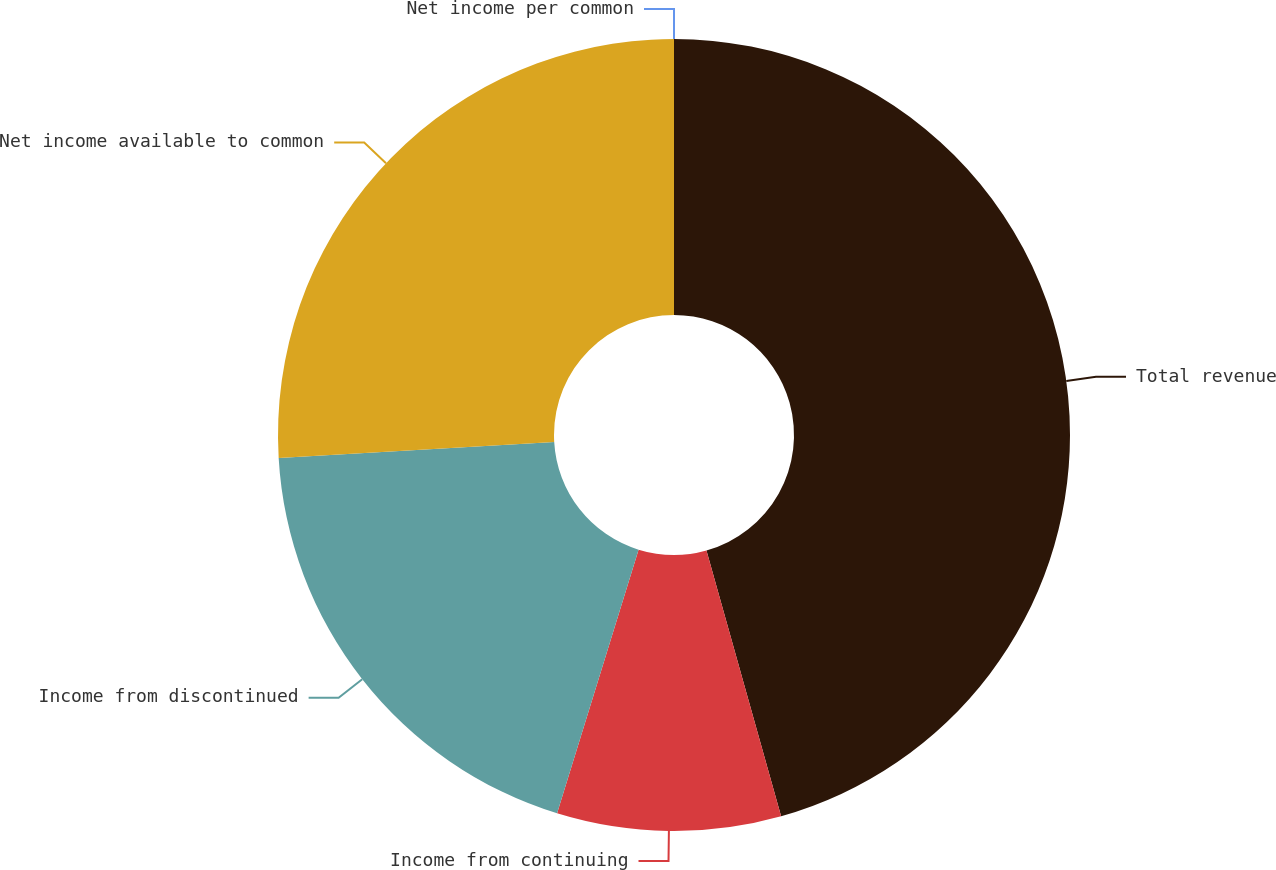<chart> <loc_0><loc_0><loc_500><loc_500><pie_chart><fcel>Total revenue<fcel>Income from continuing<fcel>Income from discontinued<fcel>Net income available to common<fcel>Net income per common<nl><fcel>45.64%<fcel>9.13%<fcel>19.31%<fcel>25.92%<fcel>0.0%<nl></chart> 